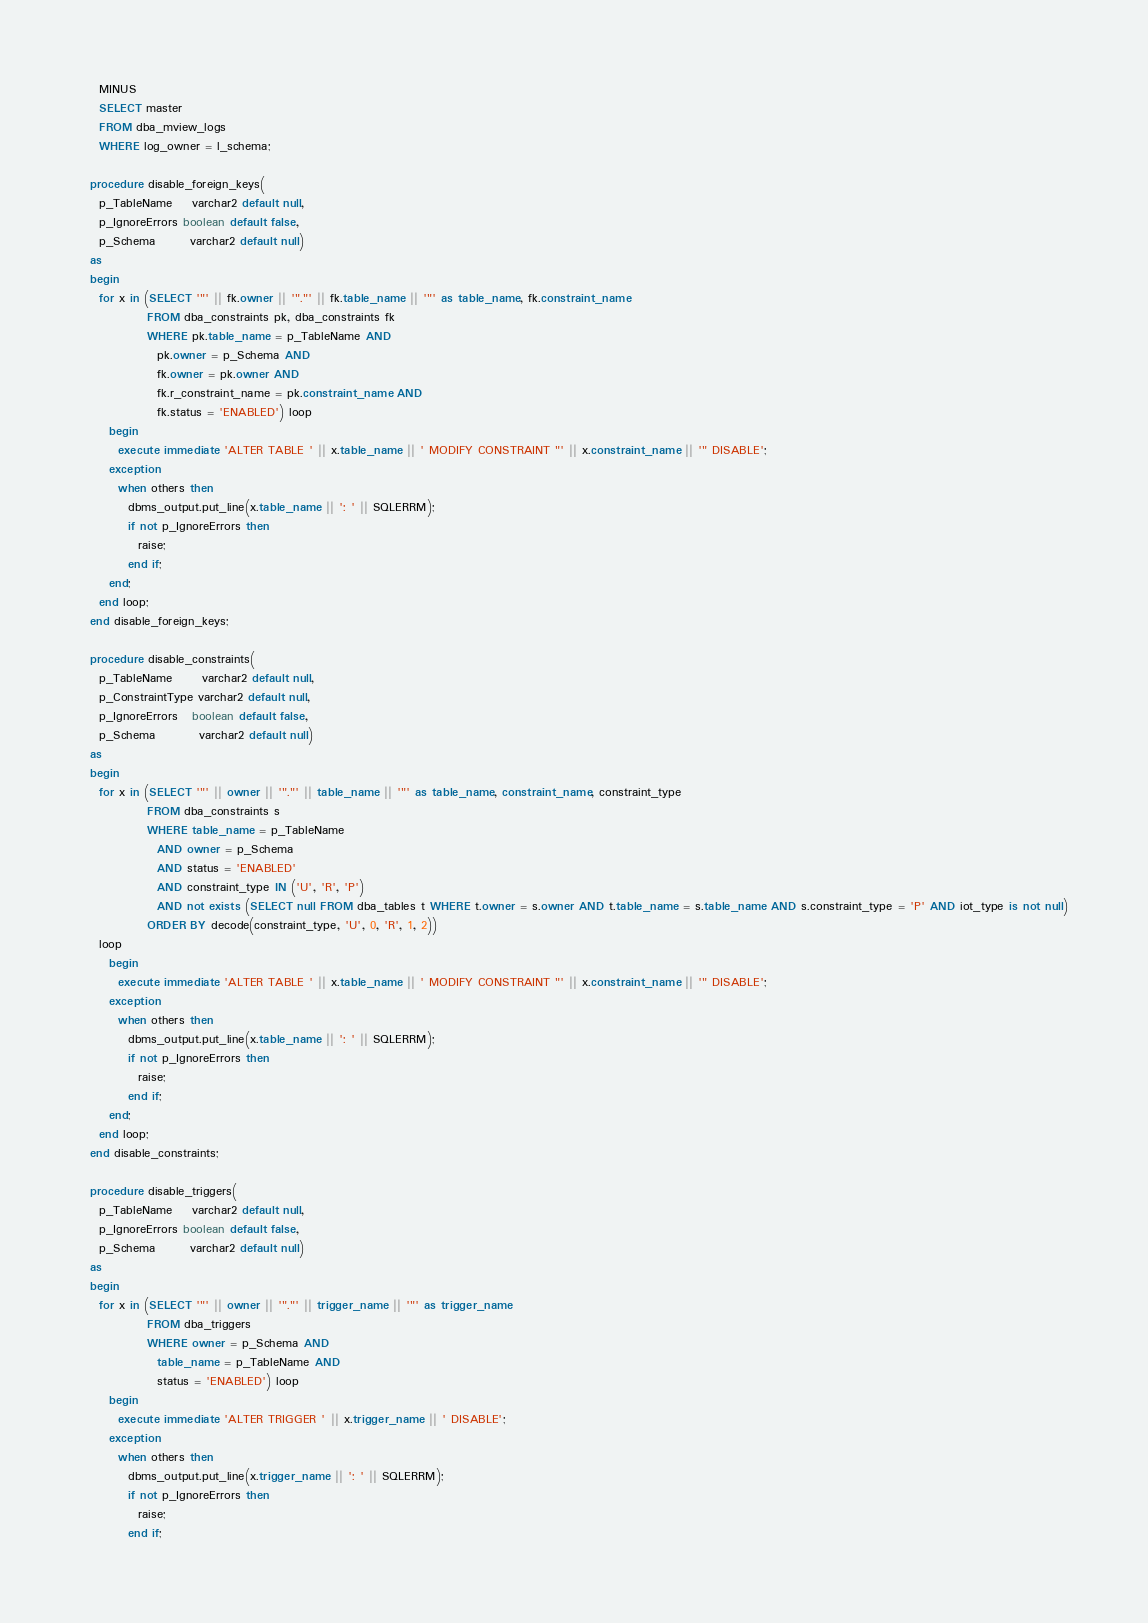Convert code to text. <code><loc_0><loc_0><loc_500><loc_500><_SQL_>    MINUS
    SELECT master
    FROM dba_mview_logs
    WHERE log_owner = l_schema;

  procedure disable_foreign_keys(
    p_TableName    varchar2 default null,
    p_IgnoreErrors boolean default false,
    p_Schema       varchar2 default null)
  as
  begin
    for x in (SELECT '"' || fk.owner || '"."' || fk.table_name || '"' as table_name, fk.constraint_name
              FROM dba_constraints pk, dba_constraints fk
              WHERE pk.table_name = p_TableName AND
                pk.owner = p_Schema AND
                fk.owner = pk.owner AND
                fk.r_constraint_name = pk.constraint_name AND
                fk.status = 'ENABLED') loop
      begin
        execute immediate 'ALTER TABLE ' || x.table_name || ' MODIFY CONSTRAINT "' || x.constraint_name || '" DISABLE';
      exception
        when others then
          dbms_output.put_line(x.table_name || ': ' || SQLERRM);
          if not p_IgnoreErrors then
            raise;
          end if;
      end;
    end loop;
  end disable_foreign_keys;

  procedure disable_constraints(
    p_TableName      varchar2 default null,
    p_ConstraintType varchar2 default null,
    p_IgnoreErrors   boolean default false,
    p_Schema         varchar2 default null)
  as
  begin
    for x in (SELECT '"' || owner || '"."' || table_name || '"' as table_name, constraint_name, constraint_type
              FROM dba_constraints s
              WHERE table_name = p_TableName
                AND owner = p_Schema
                AND status = 'ENABLED'
                AND constraint_type IN ('U', 'R', 'P')
                AND not exists (SELECT null FROM dba_tables t WHERE t.owner = s.owner AND t.table_name = s.table_name AND s.constraint_type = 'P' AND iot_type is not null)
              ORDER BY decode(constraint_type, 'U', 0, 'R', 1, 2))
    loop
      begin
        execute immediate 'ALTER TABLE ' || x.table_name || ' MODIFY CONSTRAINT "' || x.constraint_name || '" DISABLE';
      exception
        when others then
          dbms_output.put_line(x.table_name || ': ' || SQLERRM);
          if not p_IgnoreErrors then
            raise;
          end if;
      end;
    end loop;
  end disable_constraints;

  procedure disable_triggers(
    p_TableName    varchar2 default null,
    p_IgnoreErrors boolean default false,
    p_Schema       varchar2 default null)
  as
  begin
    for x in (SELECT '"' || owner || '"."' || trigger_name || '"' as trigger_name
              FROM dba_triggers
              WHERE owner = p_Schema AND
                table_name = p_TableName AND
                status = 'ENABLED') loop
      begin
        execute immediate 'ALTER TRIGGER ' || x.trigger_name || ' DISABLE';
      exception
        when others then
          dbms_output.put_line(x.trigger_name || ': ' || SQLERRM);
          if not p_IgnoreErrors then
            raise;
          end if;</code> 